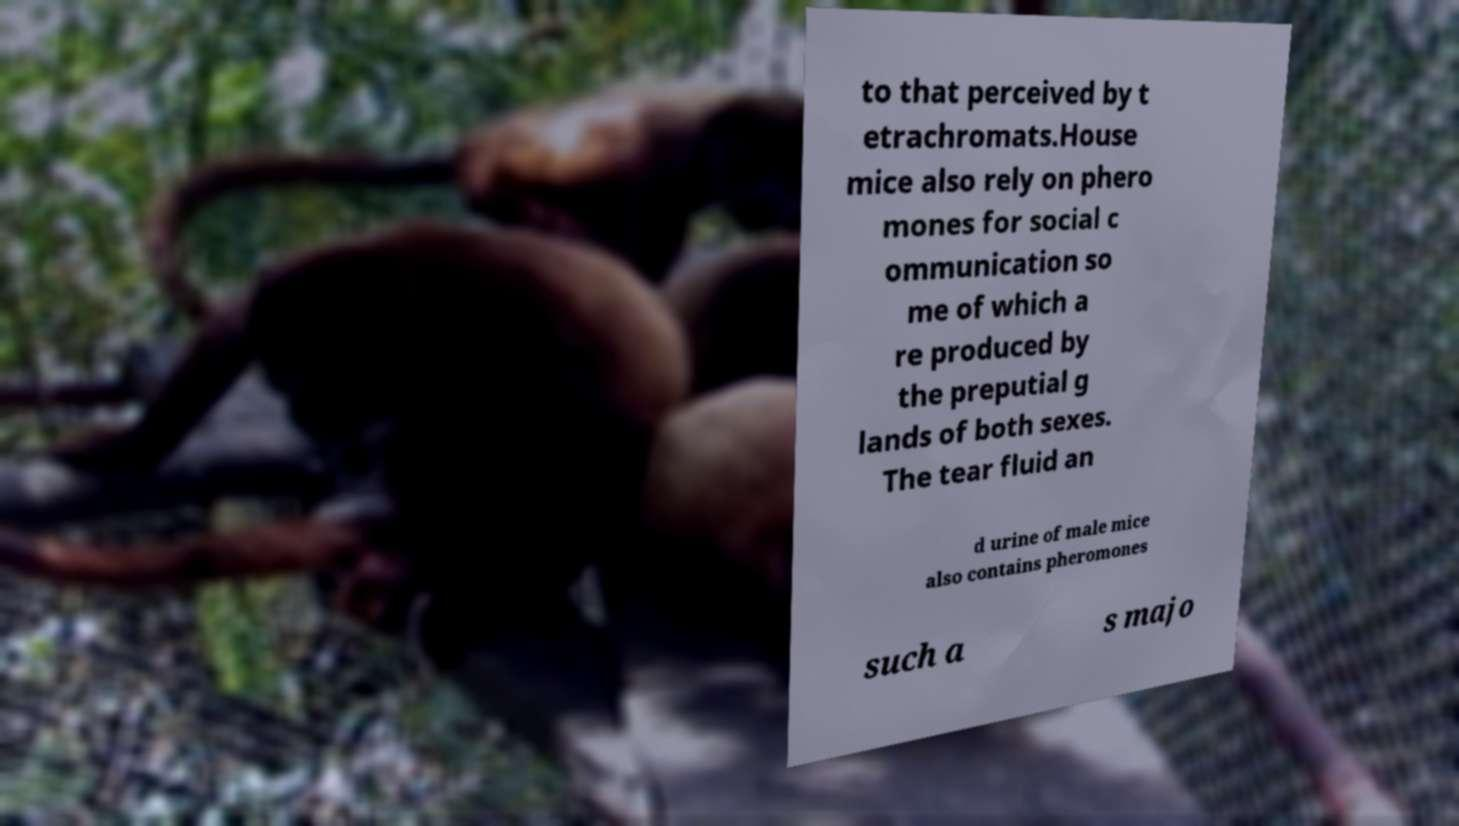I need the written content from this picture converted into text. Can you do that? to that perceived by t etrachromats.House mice also rely on phero mones for social c ommunication so me of which a re produced by the preputial g lands of both sexes. The tear fluid an d urine of male mice also contains pheromones such a s majo 